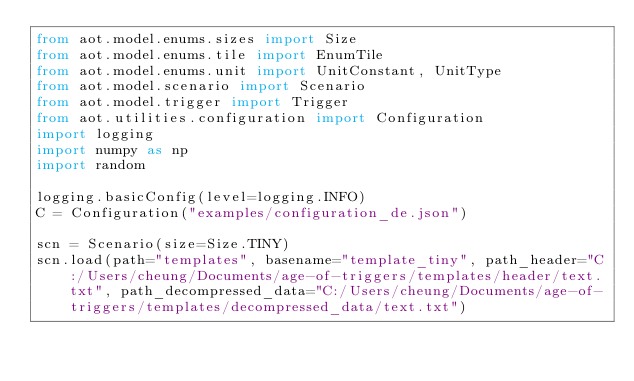<code> <loc_0><loc_0><loc_500><loc_500><_Python_>from aot.model.enums.sizes import Size
from aot.model.enums.tile import EnumTile
from aot.model.enums.unit import UnitConstant, UnitType
from aot.model.scenario import Scenario
from aot.model.trigger import Trigger
from aot.utilities.configuration import Configuration
import logging
import numpy as np
import random

logging.basicConfig(level=logging.INFO)
C = Configuration("examples/configuration_de.json")

scn = Scenario(size=Size.TINY)
scn.load(path="templates", basename="template_tiny", path_header="C:/Users/cheung/Documents/age-of-triggers/templates/header/text.txt", path_decompressed_data="C:/Users/cheung/Documents/age-of-triggers/templates/decompressed_data/text.txt")
</code> 